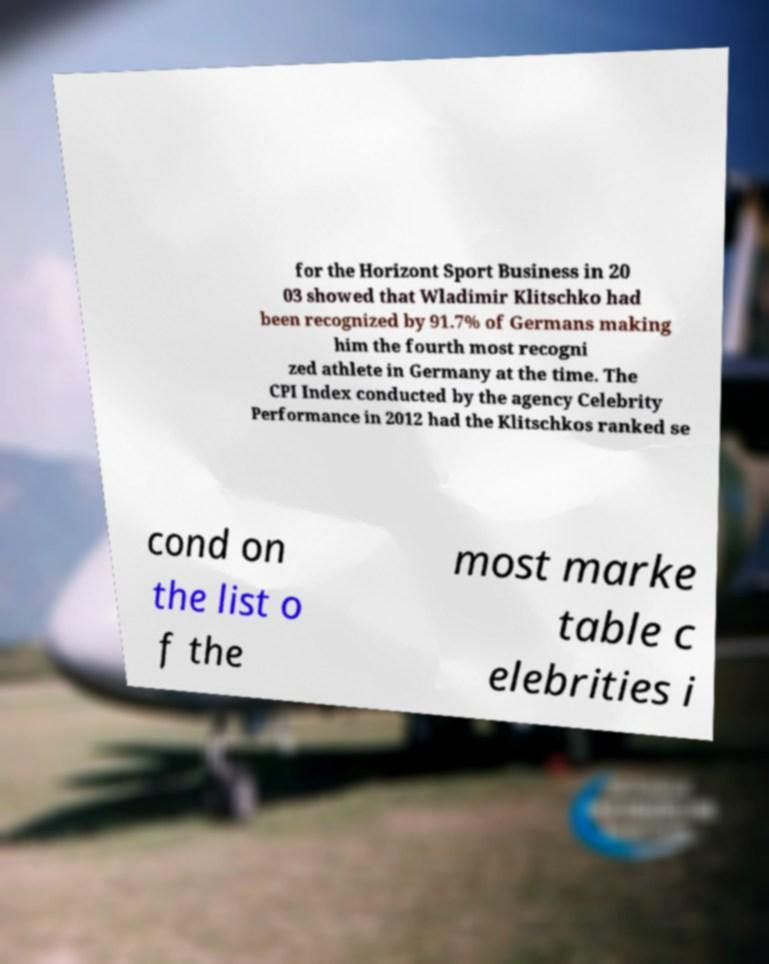I need the written content from this picture converted into text. Can you do that? for the Horizont Sport Business in 20 03 showed that Wladimir Klitschko had been recognized by 91.7% of Germans making him the fourth most recogni zed athlete in Germany at the time. The CPI Index conducted by the agency Celebrity Performance in 2012 had the Klitschkos ranked se cond on the list o f the most marke table c elebrities i 